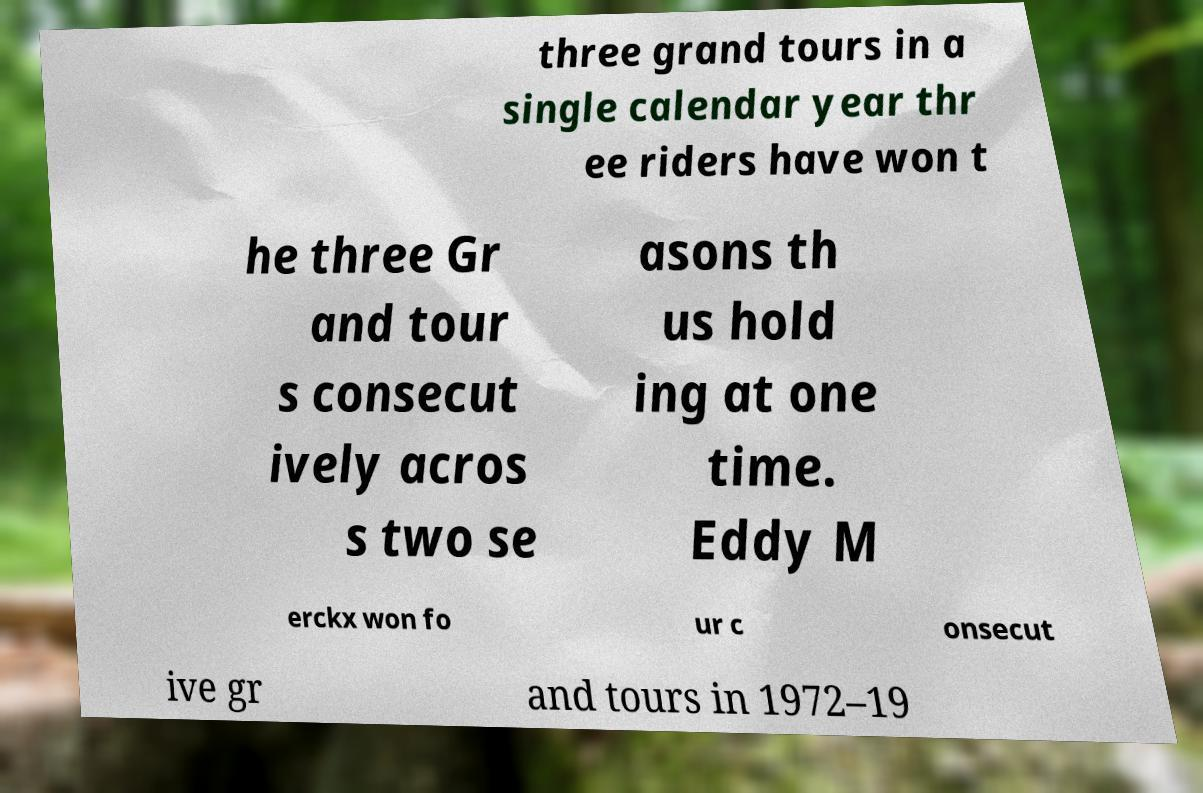Please read and relay the text visible in this image. What does it say? three grand tours in a single calendar year thr ee riders have won t he three Gr and tour s consecut ively acros s two se asons th us hold ing at one time. Eddy M erckx won fo ur c onsecut ive gr and tours in 1972–19 